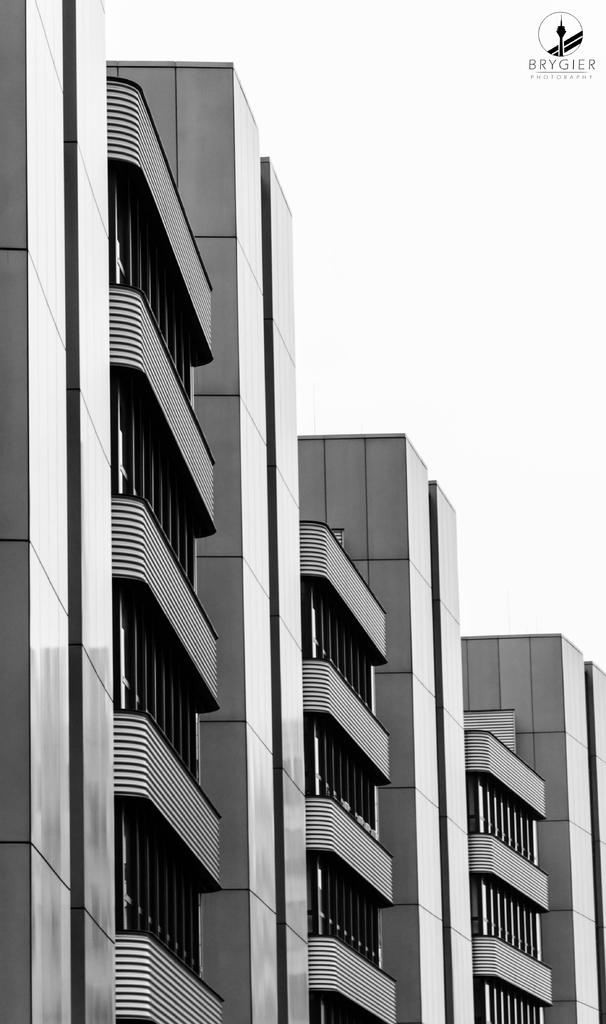What type of subject matter is featured in the image? The image contains the architecture of buildings. Is there any additional information or branding present in the image? Yes, there is a watermark in the top right corner of the image. What can be seen in the background of the image? The sky is visible in the image. What type of cloth is draped over the buildings in the image? There is no cloth draped over the buildings in the image; it features the architecture of buildings without any additional elements. How many snakes can be seen slithering around the buildings in the image? There are no snakes present in the image; it only contains the architecture of buildings and the sky in the background. 